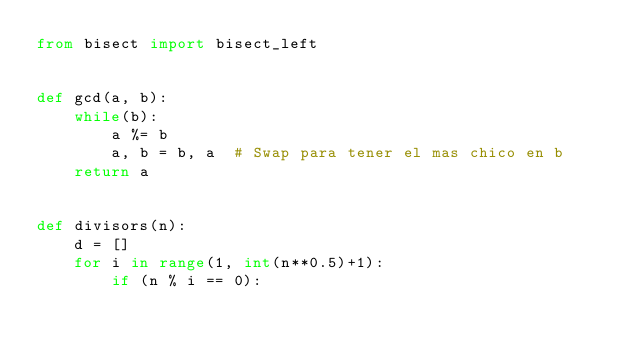Convert code to text. <code><loc_0><loc_0><loc_500><loc_500><_Python_>from bisect import bisect_left


def gcd(a, b):
    while(b):
        a %= b
        a, b = b, a  # Swap para tener el mas chico en b
    return a


def divisors(n):
    d = []
    for i in range(1, int(n**0.5)+1):
        if (n % i == 0):</code> 